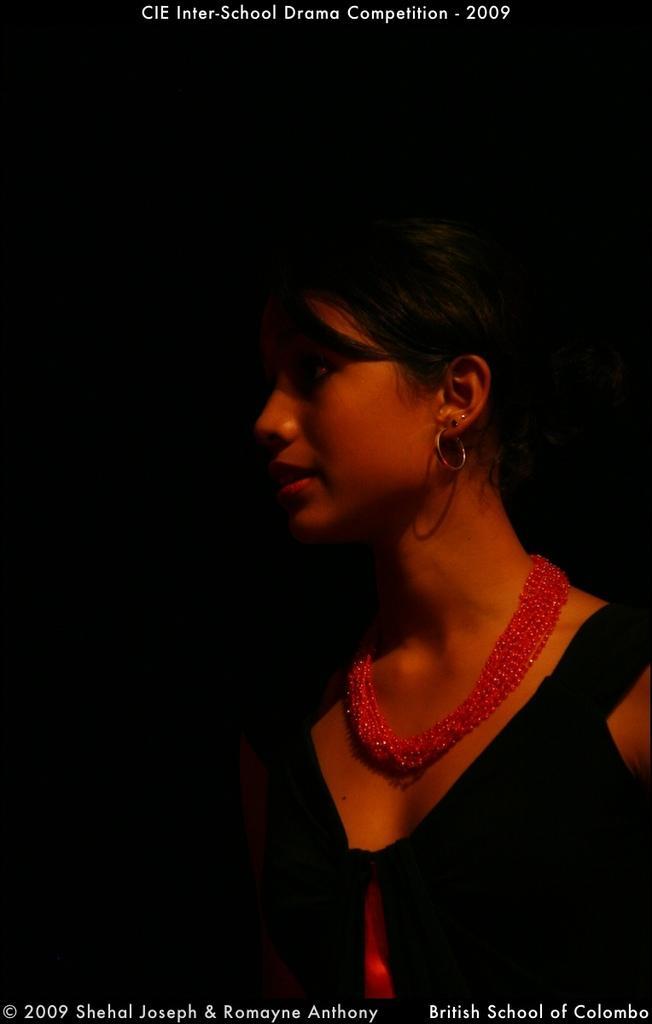Please provide a concise description of this image. In this image we can see a woman. We can also see some text on this image. 